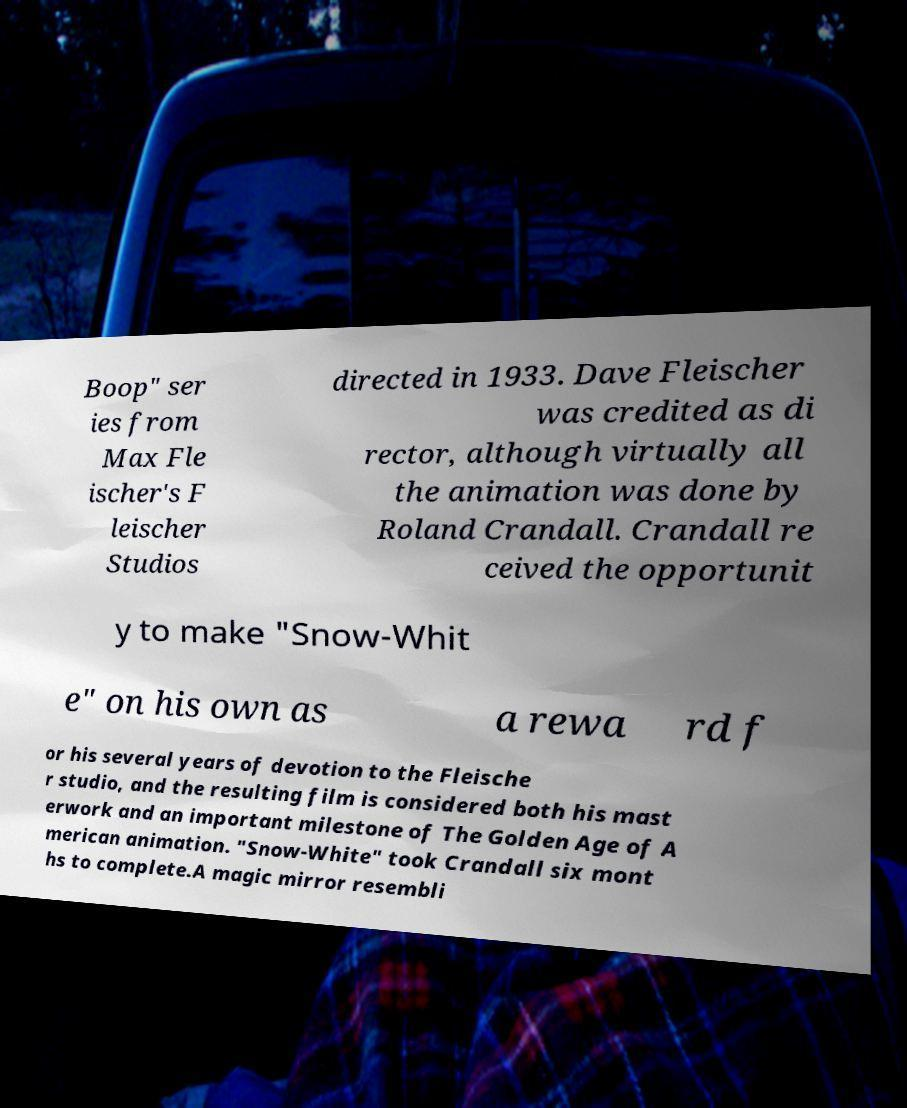Please identify and transcribe the text found in this image. Boop" ser ies from Max Fle ischer's F leischer Studios directed in 1933. Dave Fleischer was credited as di rector, although virtually all the animation was done by Roland Crandall. Crandall re ceived the opportunit y to make "Snow-Whit e" on his own as a rewa rd f or his several years of devotion to the Fleische r studio, and the resulting film is considered both his mast erwork and an important milestone of The Golden Age of A merican animation. "Snow-White" took Crandall six mont hs to complete.A magic mirror resembli 